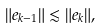Convert formula to latex. <formula><loc_0><loc_0><loc_500><loc_500>\| e _ { k - 1 } \| \lesssim \| e _ { k } \| ,</formula> 